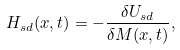Convert formula to latex. <formula><loc_0><loc_0><loc_500><loc_500>H _ { s d } ( x , t ) = - \frac { \delta U _ { s d } } { \delta M ( x , t ) } ,</formula> 